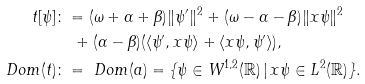<formula> <loc_0><loc_0><loc_500><loc_500>t [ \psi ] & \colon = ( \omega + \alpha + \beta ) \| \psi ^ { \prime } \| ^ { 2 } + ( \omega - \alpha - \beta ) \| x \psi \| ^ { 2 } \\ & \quad + ( \alpha - \beta ) ( \langle \psi ^ { \prime } , x \psi \rangle + \langle x \psi , \psi ^ { \prime } \rangle ) , \\ \ D o m ( t ) & \colon = \ D o m ( a ) = \{ \psi \in W ^ { 1 , 2 } ( \mathbb { R } ) \, | \, x \psi \in L ^ { 2 } ( \mathbb { R } ) \} .</formula> 